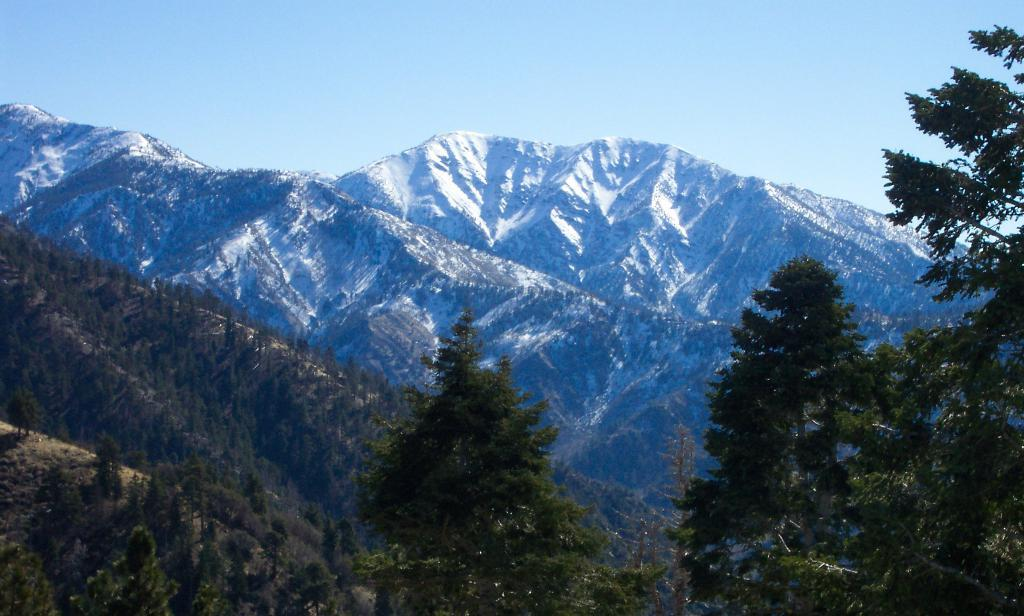What type of natural features can be seen in the image? There are trees and mountains in the image. What part of the natural environment is visible in the image? The sky is visible in the image. What type of rod is being used to play the guitar in the image? There is no guitar or rod present in the image; it features trees, mountains, and the sky. 